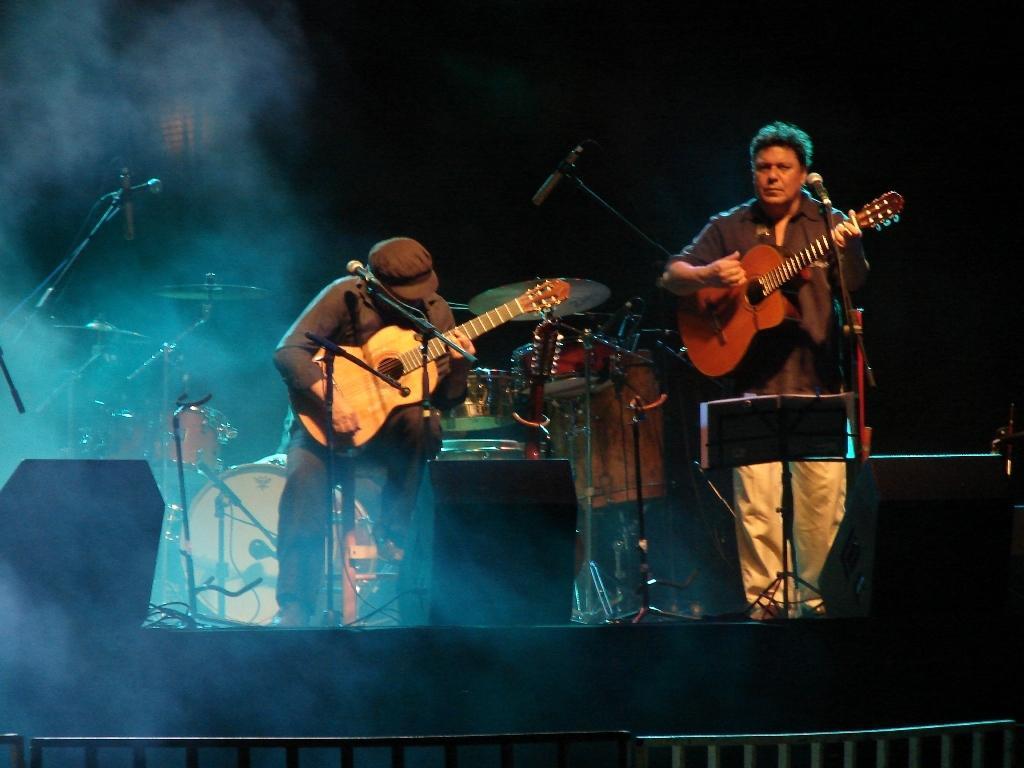Could you give a brief overview of what you see in this image? In this image there are two people. The man in the center is playing a guitar. On the right there is another man who is standing and holding a guitar in his hand. There are mics placed before them. In the background there is a band. 